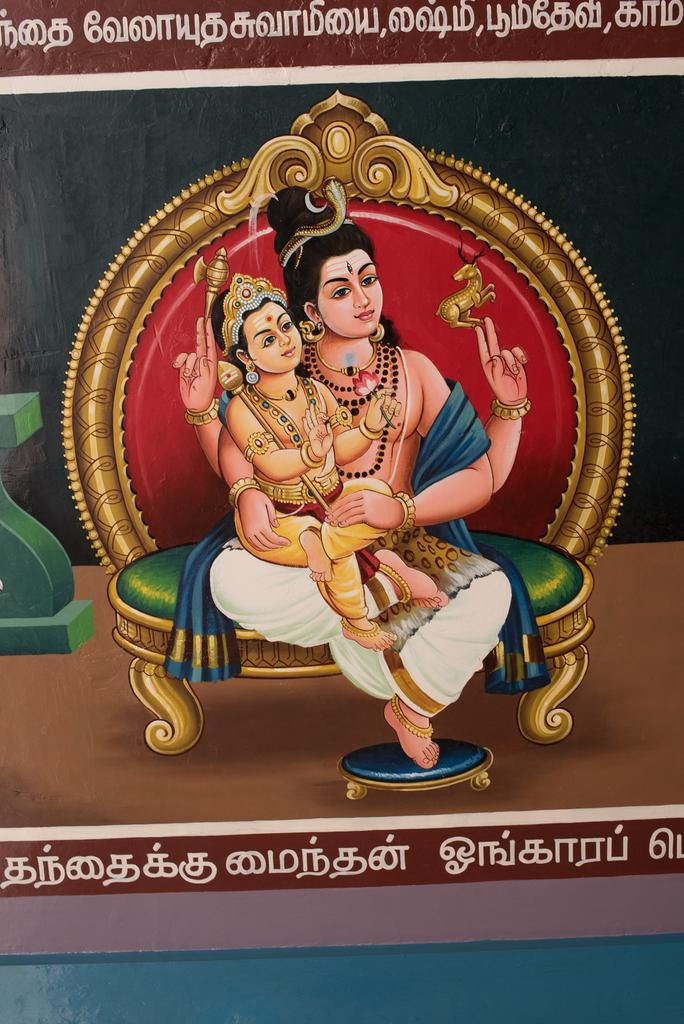What is the main subject in the center of the image? There is a poster in the center of the image. What is depicted on the poster? The poster features a man and a baby. What are the man and the baby doing on the poster? They are sitting in the center of the poster. What are they sitting on? They are sitting on a chair. What type of cloud is present in the image? There is no cloud present in the image; it features a poster with a man and a baby sitting on a chair. What is the fireman doing in the image? There is no fireman present in the image; it features a poster with a man and a baby sitting on a chair. 